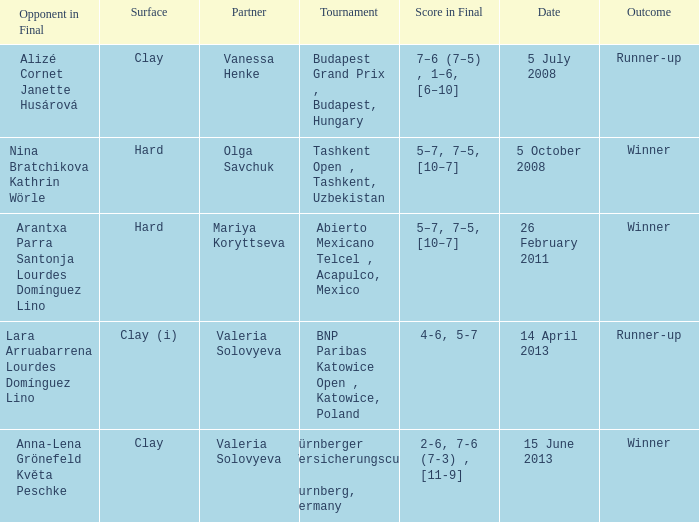Name the outcome that had an opponent in final of nina bratchikova kathrin wörle Winner. 